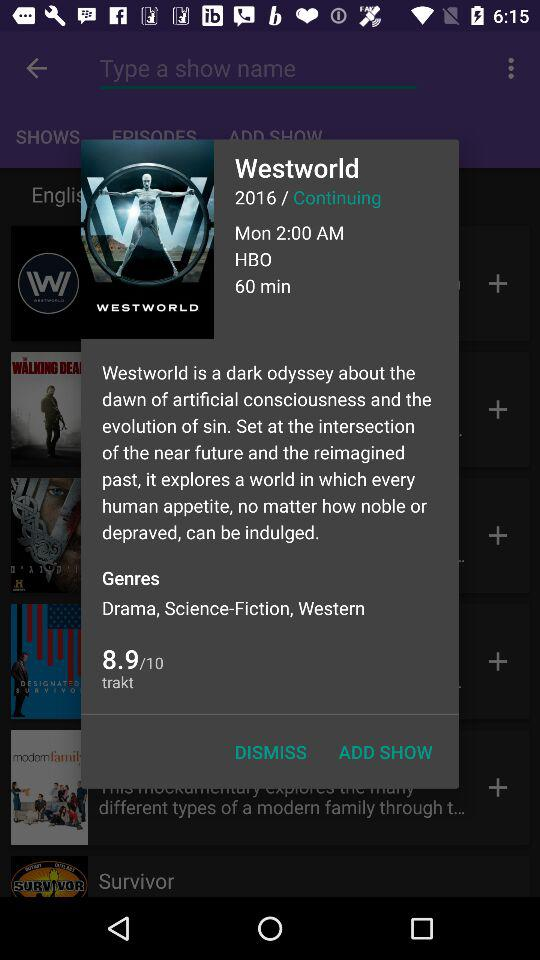What is the selected time and day? The selected time and day are 2:00 AM and Monday. 